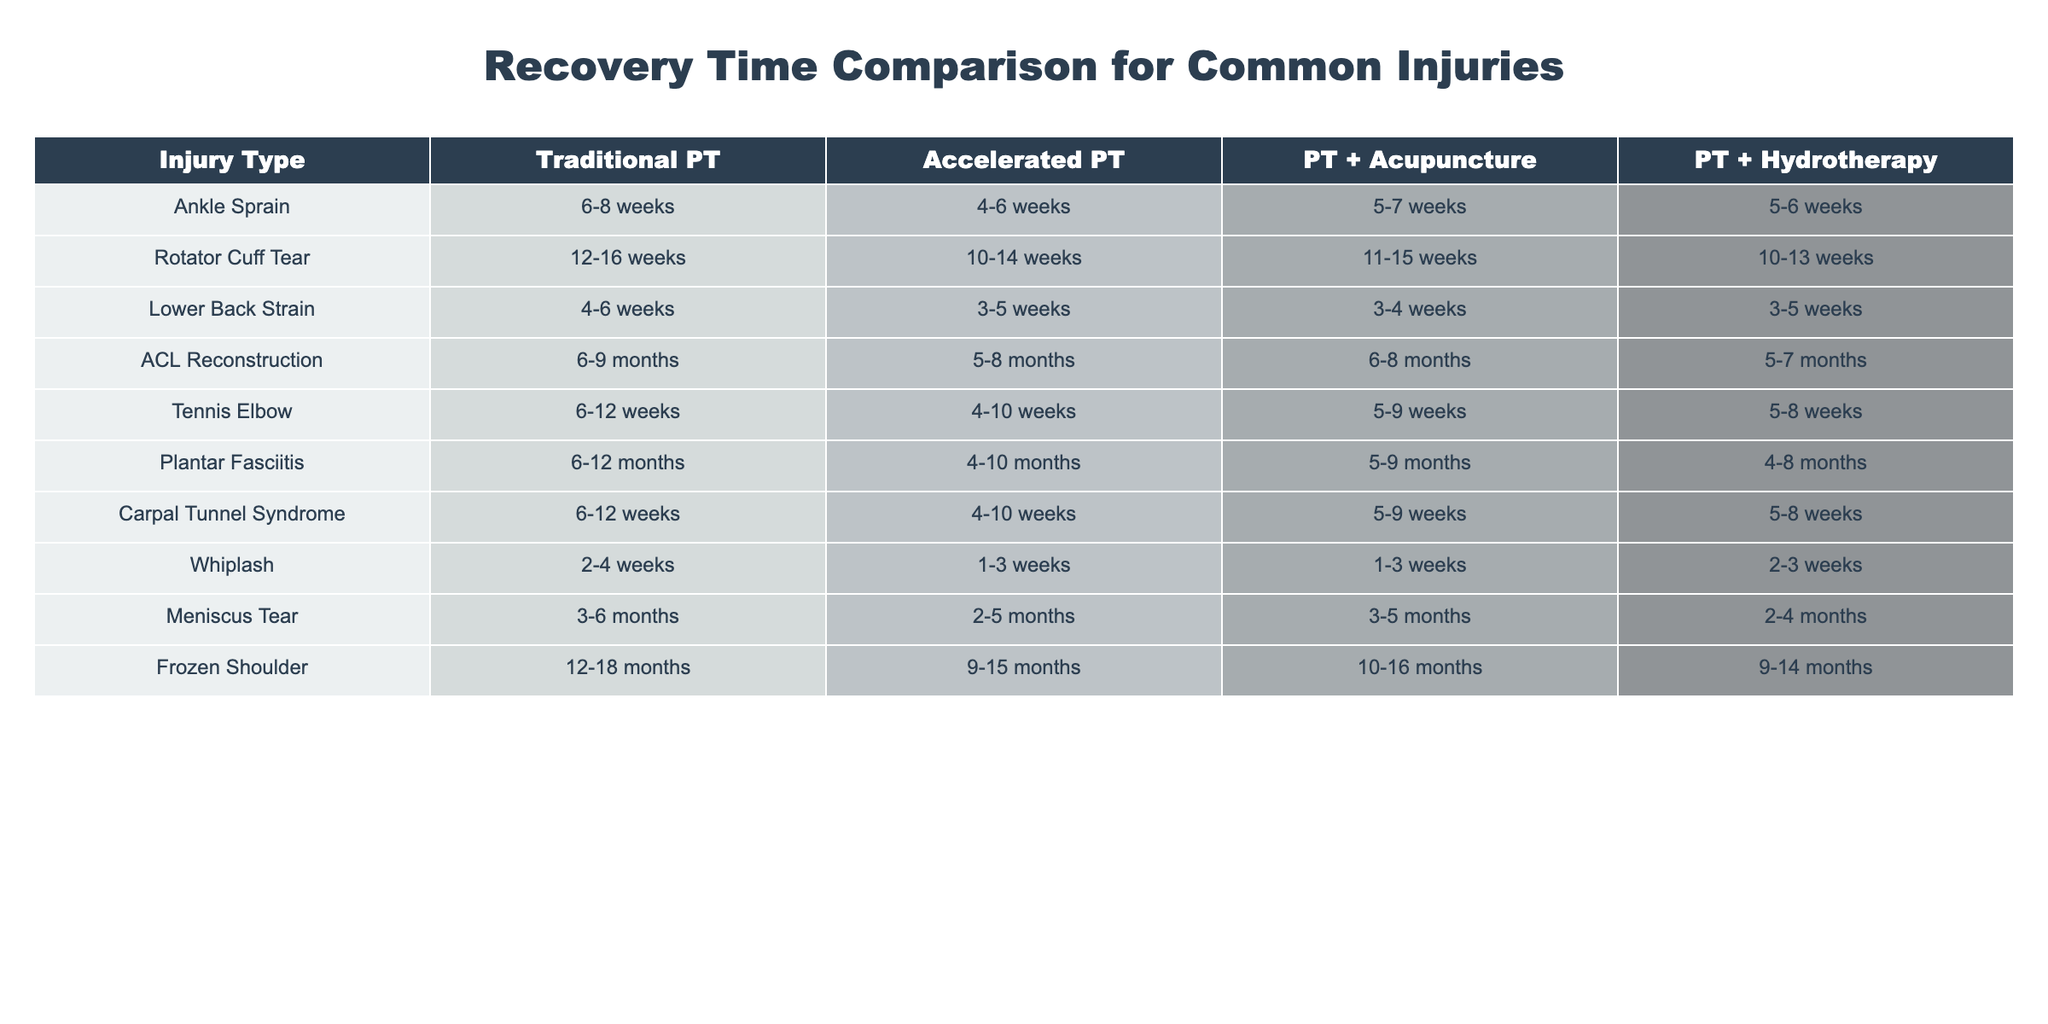What is the recovery time range for an Ankle Sprain using Traditional PT? The table shows that for an Ankle Sprain treated with Traditional PT, the recovery time range is 6-8 weeks.
Answer: 6-8 weeks Which therapy approach has the shortest recovery time for a Lower Back Strain? For Lower Back Strain, the table indicates that Accelerated PT has the shortest recovery time, ranging from 3-5 weeks.
Answer: Accelerated PT What is the difference in recovery time for Rotator Cuff Tear between Traditional PT and PT + Hydrotherapy? Traditional PT recovery time for Rotator Cuff Tear is 12-16 weeks, while PT + Hydrotherapy is 10-13 weeks. The difference is (12-16) - (10-13) which equals a maximum range of 4 to 3 weeks shorter with PT + Hydrotherapy.
Answer: Up to 4 weeks For Tennis Elbow, what is the average recovery time for all therapy approaches? The recovery times for Tennis Elbow are: Traditional PT (6-12 weeks), Accelerated PT (4-10 weeks), PT + Acupuncture (5-9 weeks), PT + Hydrotherapy (5-8 weeks). The average recovery time can be found by taking the midpoints of each range: (9 weeks, 7 weeks, 7 weeks, 6.5 weeks), which gives an average of about 7.25 weeks.
Answer: Approximately 7.25 weeks Is PT + Acupuncture the fastest option for treating Plantar Fasciitis? According to the table, the recovery time for PT + Acupuncture for Plantar Fasciitis is 5-9 months, while Accelerated PT is 4-10 months, which indicates that PT + Acupuncture is not the fastest option.
Answer: No What therapy approach has the longest recovery time for Frozen Shoulder? The longest recovery time listed for Frozen Shoulder is with Traditional PT, which has a recovery range of 12-18 months.
Answer: Traditional PT How much faster is recovery for Whiplash using Accelerated PT compared to Traditional PT? The recovery times for Whiplash are 2-4 weeks with Traditional PT and 1-3 weeks with Accelerated PT. The difference can be calculated as follows: for Traditional PT, the maximum is 4 weeks and for Accelerated PT, it’s 3 weeks, giving a difference of 1 week at maximum.
Answer: Up to 1 week Which two therapies have the same recovery time range for Carpal Tunnel Syndrome? From the table, both PT + Acupuncture and PT + Hydrotherapy have the same recovery time for Carpal Tunnel Syndrome (5-9 weeks).
Answer: PT + Acupuncture and PT + Hydrotherapy What is the combined recovery time for an ACL Reconstruction when using both Accelerated PT and PT + Hydrotherapy? The recovery for Accelerated PT is 5-8 months while PT + Hydrotherapy is 5-7 months. The combined highest time would be the longest duration from each approach, so it would be 8 months at max.
Answer: Up to 8 months For Meniscus Tear, which two therapy approaches are the most efficient in terms of recovery time? The fastest recovery times for Meniscus Tear are from PT + Hydrotherapy (2-4 months) and Accelerated PT (2-5 months). Both have a maximum of 5 months for the longest duration and thus are the most efficient therapies listed.
Answer: PT + Hydrotherapy and Accelerated PT 